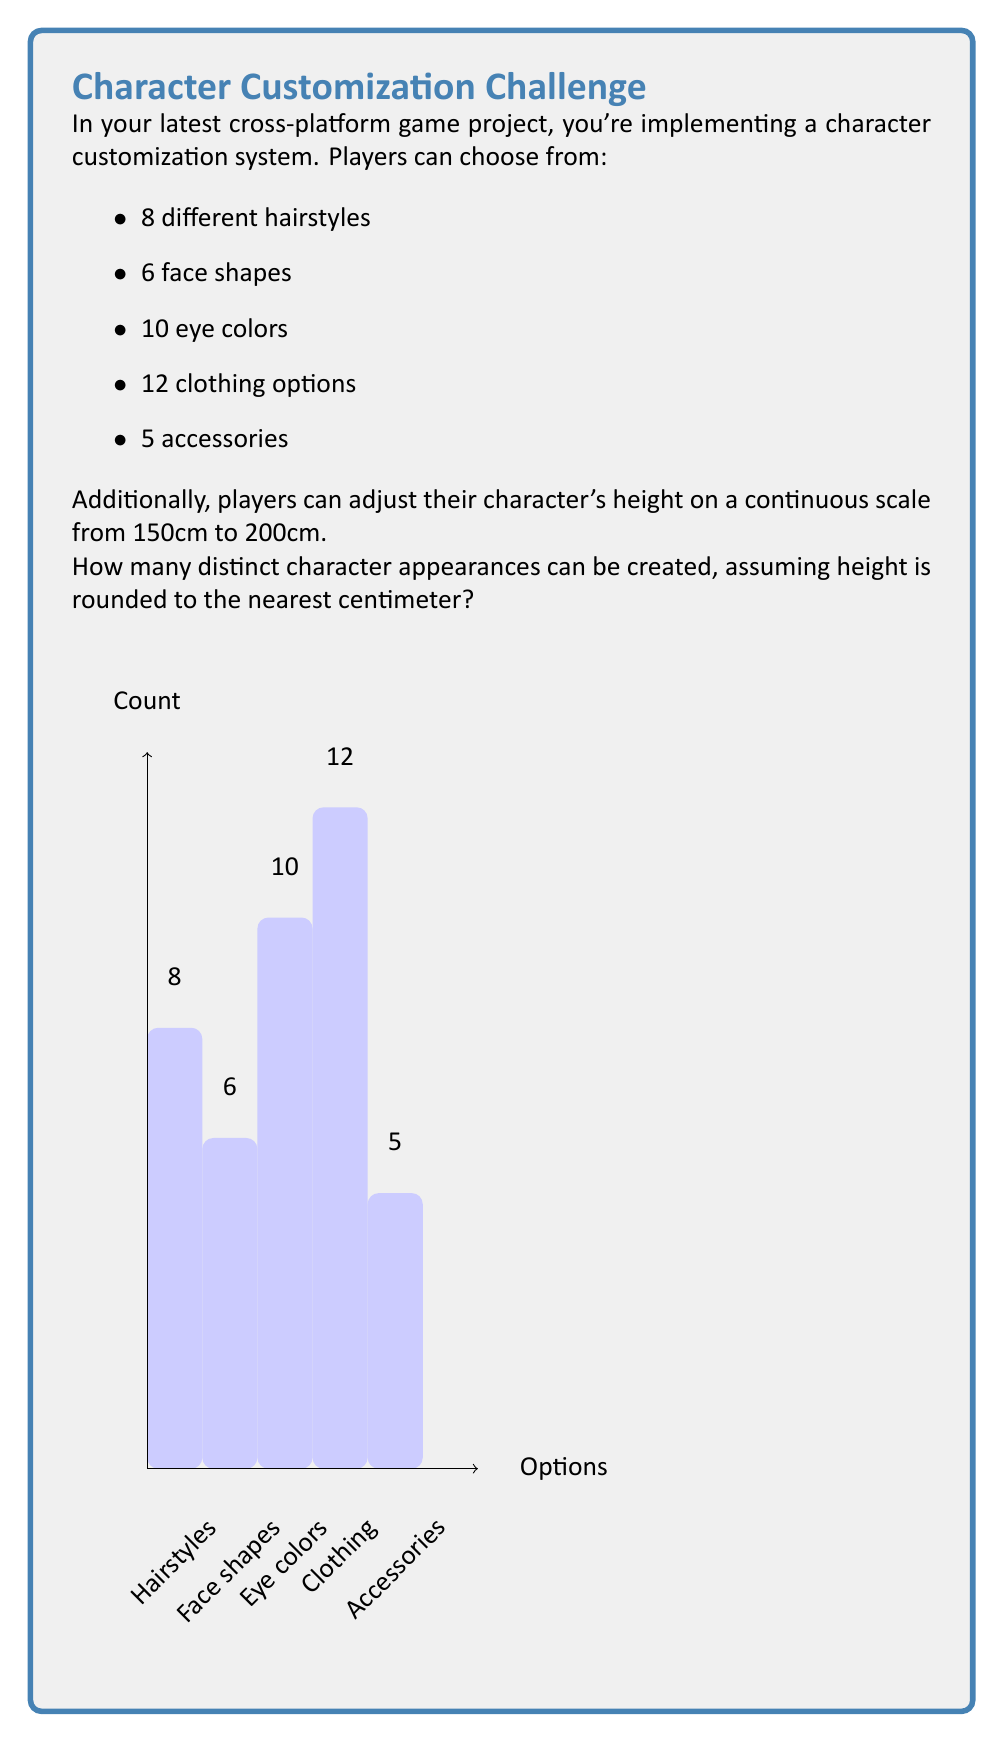Teach me how to tackle this problem. Let's break this down step-by-step:

1) First, let's calculate the number of combinations for the discrete options:
   
   $$ 8 \text{ (hairstyles)} \times 6 \text{ (face shapes)} \times 10 \text{ (eye colors)} \times 12 \text{ (clothing)} \times 5 \text{ (accessories)} $$
   
   $$ = 8 \times 6 \times 10 \times 12 \times 5 = 28,800 $$

2) Now, for the height:
   The range is from 150cm to 200cm, rounded to the nearest centimeter.
   This means there are 51 possible height options (150, 151, 152, ..., 200).

3) To get the total number of combinations, we multiply the number of discrete combinations by the number of height options:

   $$ 28,800 \times 51 = 1,468,800 $$

Therefore, there are 1,468,800 distinct character appearances possible.
Answer: 1,468,800 